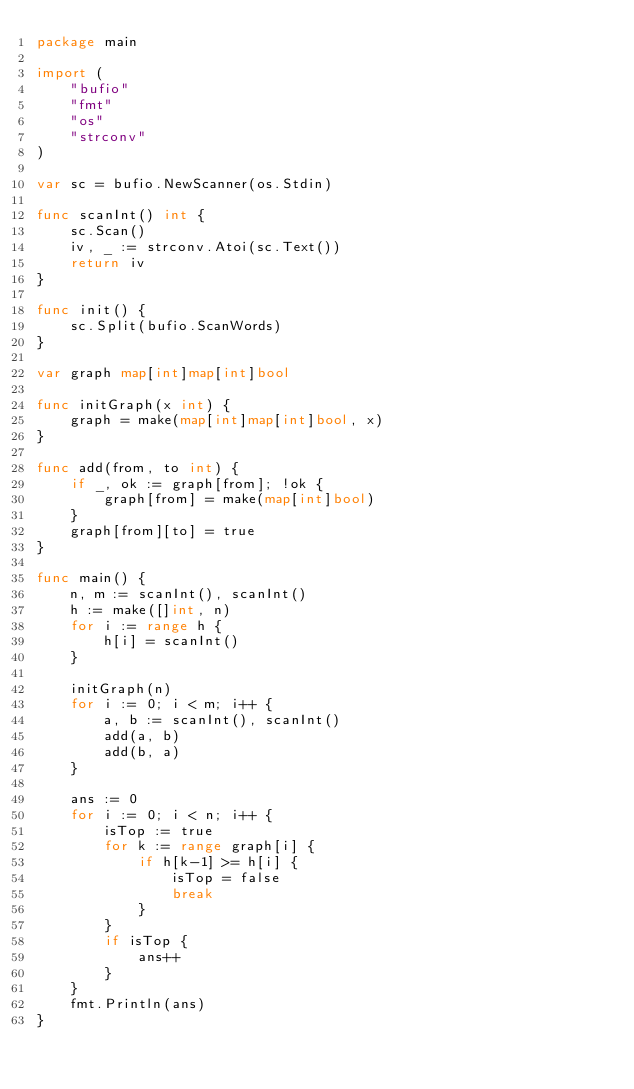Convert code to text. <code><loc_0><loc_0><loc_500><loc_500><_Go_>package main

import (
	"bufio"
	"fmt"
	"os"
	"strconv"
)

var sc = bufio.NewScanner(os.Stdin)

func scanInt() int {
	sc.Scan()
	iv, _ := strconv.Atoi(sc.Text())
	return iv
}

func init() {
	sc.Split(bufio.ScanWords)
}

var graph map[int]map[int]bool

func initGraph(x int) {
	graph = make(map[int]map[int]bool, x)
}

func add(from, to int) {
	if _, ok := graph[from]; !ok {
		graph[from] = make(map[int]bool)
	}
	graph[from][to] = true
}

func main() {
	n, m := scanInt(), scanInt()
	h := make([]int, n)
	for i := range h {
		h[i] = scanInt()
	}

	initGraph(n)
	for i := 0; i < m; i++ {
		a, b := scanInt(), scanInt()
		add(a, b)
		add(b, a)
	}

	ans := 0
	for i := 0; i < n; i++ {
		isTop := true
		for k := range graph[i] {
			if h[k-1] >= h[i] {
				isTop = false
				break
			}
		}
		if isTop {
			ans++
		}
	}
	fmt.Println(ans)
}
</code> 